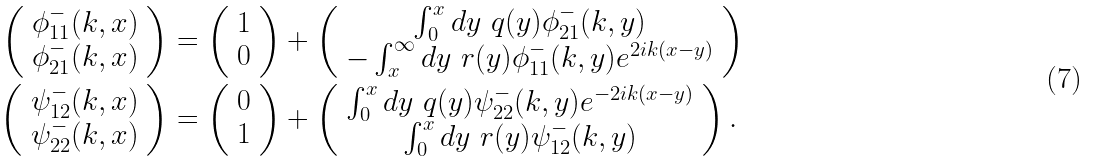<formula> <loc_0><loc_0><loc_500><loc_500>\left ( \begin{array} { c } \phi _ { 1 1 } ^ { - } ( k , x ) \\ \phi _ { 2 1 } ^ { - } ( k , x ) \end{array} \right ) & = \left ( \begin{array} { c } 1 \\ 0 \end{array} \right ) + \left ( \begin{array} { c } \int _ { 0 } ^ { x } d y \ q ( y ) \phi _ { 2 1 } ^ { - } ( k , y ) \\ - \int _ { x } ^ { \infty } d y \ r ( y ) \phi _ { 1 1 } ^ { - } ( k , y ) e ^ { 2 i k ( x - y ) } \end{array} \right ) \\ \left ( \begin{array} { c } \psi _ { 1 2 } ^ { - } ( k , x ) \\ \psi _ { 2 2 } ^ { - } ( k , x ) \end{array} \right ) & = \left ( \begin{array} { c } 0 \\ 1 \end{array} \right ) + \left ( \begin{array} { c } \int _ { 0 } ^ { x } d y \ q ( y ) \psi _ { 2 2 } ^ { - } ( k , y ) e ^ { - 2 i k ( x - y ) } \\ \int _ { 0 } ^ { x } d y \ r ( y ) \psi _ { 1 2 } ^ { - } ( k , y ) \end{array} \right ) .</formula> 